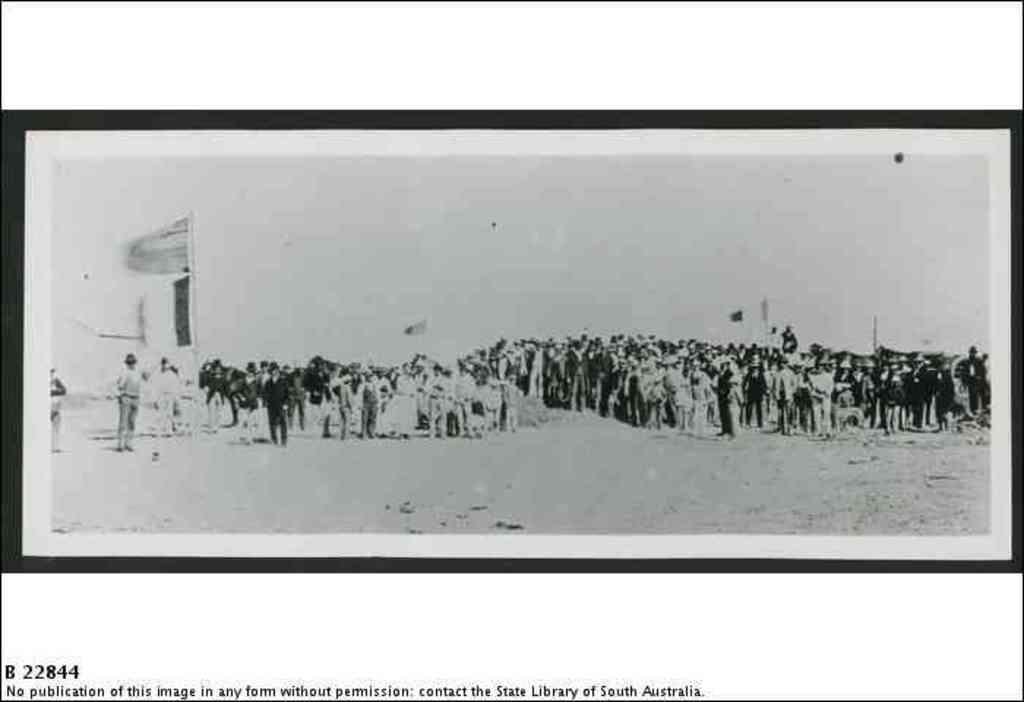<image>
Provide a brief description of the given image. An old black and white photo of a large group of people with a note underneath that the photo can not be published. 